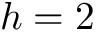Convert formula to latex. <formula><loc_0><loc_0><loc_500><loc_500>h = 2</formula> 